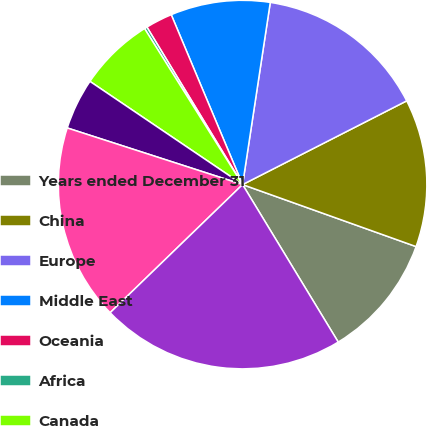<chart> <loc_0><loc_0><loc_500><loc_500><pie_chart><fcel>Years ended December 31<fcel>China<fcel>Europe<fcel>Middle East<fcel>Oceania<fcel>Africa<fcel>Canada<fcel>Latin America Caribbean and<fcel>United States<fcel>Total revenues<nl><fcel>10.85%<fcel>12.97%<fcel>15.09%<fcel>8.73%<fcel>2.36%<fcel>0.24%<fcel>6.61%<fcel>4.49%<fcel>17.21%<fcel>21.45%<nl></chart> 